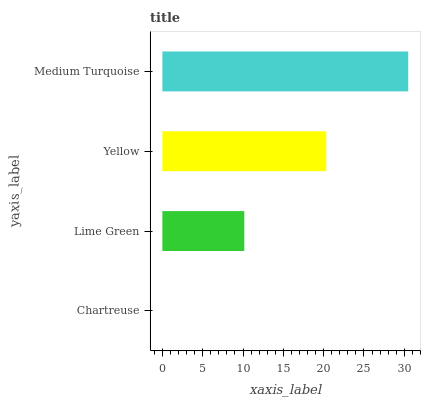Is Chartreuse the minimum?
Answer yes or no. Yes. Is Medium Turquoise the maximum?
Answer yes or no. Yes. Is Lime Green the minimum?
Answer yes or no. No. Is Lime Green the maximum?
Answer yes or no. No. Is Lime Green greater than Chartreuse?
Answer yes or no. Yes. Is Chartreuse less than Lime Green?
Answer yes or no. Yes. Is Chartreuse greater than Lime Green?
Answer yes or no. No. Is Lime Green less than Chartreuse?
Answer yes or no. No. Is Yellow the high median?
Answer yes or no. Yes. Is Lime Green the low median?
Answer yes or no. Yes. Is Medium Turquoise the high median?
Answer yes or no. No. Is Yellow the low median?
Answer yes or no. No. 